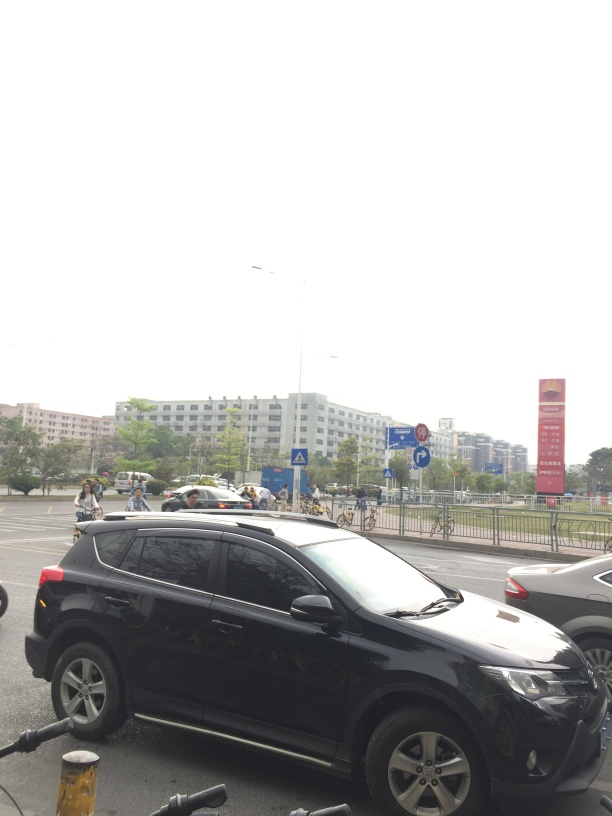Are there any quality issues with this image? Yes, the image appears overexposed, causing the sky and some areas to lack detail, and there is a slightly obstructed view due to the angle and objects in the foreground like the vehicle and bicycle. 